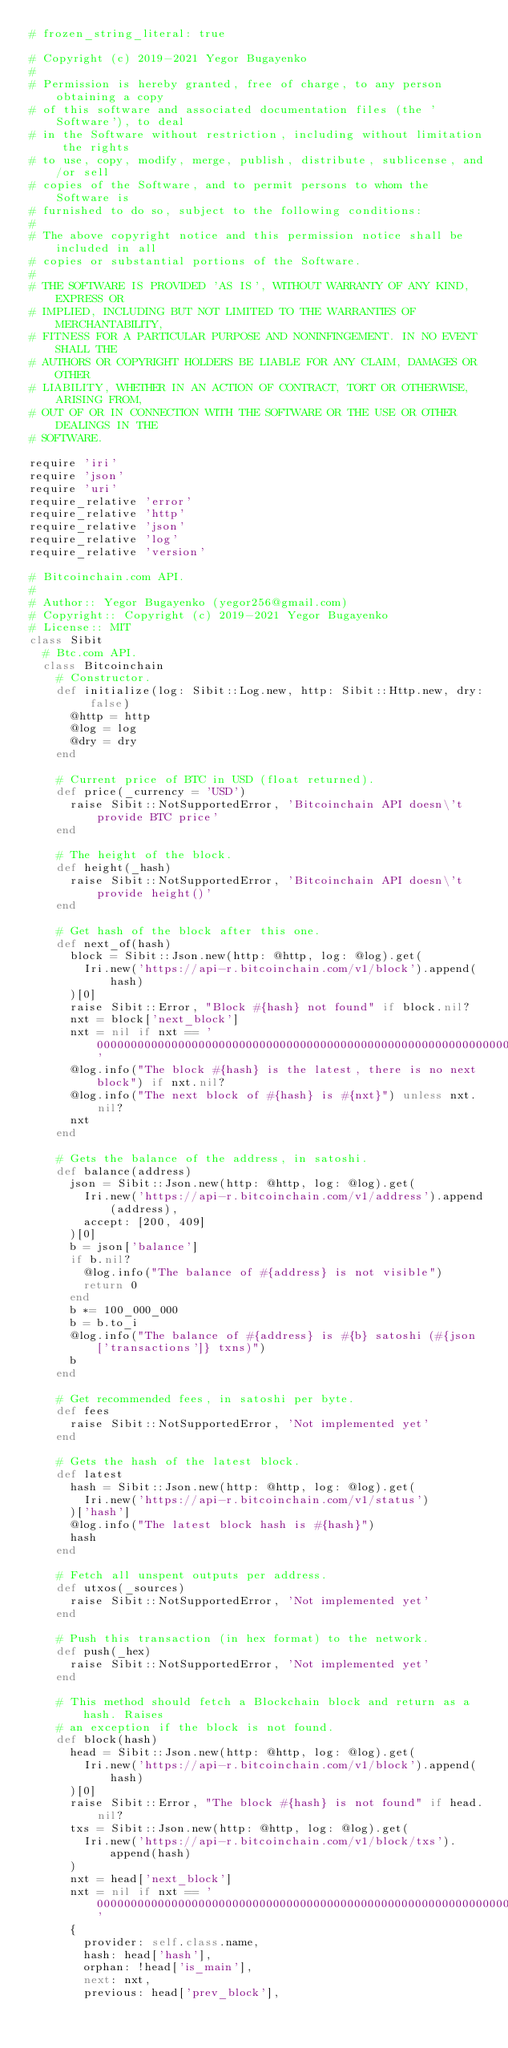<code> <loc_0><loc_0><loc_500><loc_500><_Ruby_># frozen_string_literal: true

# Copyright (c) 2019-2021 Yegor Bugayenko
#
# Permission is hereby granted, free of charge, to any person obtaining a copy
# of this software and associated documentation files (the 'Software'), to deal
# in the Software without restriction, including without limitation the rights
# to use, copy, modify, merge, publish, distribute, sublicense, and/or sell
# copies of the Software, and to permit persons to whom the Software is
# furnished to do so, subject to the following conditions:
#
# The above copyright notice and this permission notice shall be included in all
# copies or substantial portions of the Software.
#
# THE SOFTWARE IS PROVIDED 'AS IS', WITHOUT WARRANTY OF ANY KIND, EXPRESS OR
# IMPLIED, INCLUDING BUT NOT LIMITED TO THE WARRANTIES OF MERCHANTABILITY,
# FITNESS FOR A PARTICULAR PURPOSE AND NONINFINGEMENT. IN NO EVENT SHALL THE
# AUTHORS OR COPYRIGHT HOLDERS BE LIABLE FOR ANY CLAIM, DAMAGES OR OTHER
# LIABILITY, WHETHER IN AN ACTION OF CONTRACT, TORT OR OTHERWISE, ARISING FROM,
# OUT OF OR IN CONNECTION WITH THE SOFTWARE OR THE USE OR OTHER DEALINGS IN THE
# SOFTWARE.

require 'iri'
require 'json'
require 'uri'
require_relative 'error'
require_relative 'http'
require_relative 'json'
require_relative 'log'
require_relative 'version'

# Bitcoinchain.com API.
#
# Author:: Yegor Bugayenko (yegor256@gmail.com)
# Copyright:: Copyright (c) 2019-2021 Yegor Bugayenko
# License:: MIT
class Sibit
  # Btc.com API.
  class Bitcoinchain
    # Constructor.
    def initialize(log: Sibit::Log.new, http: Sibit::Http.new, dry: false)
      @http = http
      @log = log
      @dry = dry
    end

    # Current price of BTC in USD (float returned).
    def price(_currency = 'USD')
      raise Sibit::NotSupportedError, 'Bitcoinchain API doesn\'t provide BTC price'
    end

    # The height of the block.
    def height(_hash)
      raise Sibit::NotSupportedError, 'Bitcoinchain API doesn\'t provide height()'
    end

    # Get hash of the block after this one.
    def next_of(hash)
      block = Sibit::Json.new(http: @http, log: @log).get(
        Iri.new('https://api-r.bitcoinchain.com/v1/block').append(hash)
      )[0]
      raise Sibit::Error, "Block #{hash} not found" if block.nil?
      nxt = block['next_block']
      nxt = nil if nxt == '0000000000000000000000000000000000000000000000000000000000000000'
      @log.info("The block #{hash} is the latest, there is no next block") if nxt.nil?
      @log.info("The next block of #{hash} is #{nxt}") unless nxt.nil?
      nxt
    end

    # Gets the balance of the address, in satoshi.
    def balance(address)
      json = Sibit::Json.new(http: @http, log: @log).get(
        Iri.new('https://api-r.bitcoinchain.com/v1/address').append(address),
        accept: [200, 409]
      )[0]
      b = json['balance']
      if b.nil?
        @log.info("The balance of #{address} is not visible")
        return 0
      end
      b *= 100_000_000
      b = b.to_i
      @log.info("The balance of #{address} is #{b} satoshi (#{json['transactions']} txns)")
      b
    end

    # Get recommended fees, in satoshi per byte.
    def fees
      raise Sibit::NotSupportedError, 'Not implemented yet'
    end

    # Gets the hash of the latest block.
    def latest
      hash = Sibit::Json.new(http: @http, log: @log).get(
        Iri.new('https://api-r.bitcoinchain.com/v1/status')
      )['hash']
      @log.info("The latest block hash is #{hash}")
      hash
    end

    # Fetch all unspent outputs per address.
    def utxos(_sources)
      raise Sibit::NotSupportedError, 'Not implemented yet'
    end

    # Push this transaction (in hex format) to the network.
    def push(_hex)
      raise Sibit::NotSupportedError, 'Not implemented yet'
    end

    # This method should fetch a Blockchain block and return as a hash. Raises
    # an exception if the block is not found.
    def block(hash)
      head = Sibit::Json.new(http: @http, log: @log).get(
        Iri.new('https://api-r.bitcoinchain.com/v1/block').append(hash)
      )[0]
      raise Sibit::Error, "The block #{hash} is not found" if head.nil?
      txs = Sibit::Json.new(http: @http, log: @log).get(
        Iri.new('https://api-r.bitcoinchain.com/v1/block/txs').append(hash)
      )
      nxt = head['next_block']
      nxt = nil if nxt == '0000000000000000000000000000000000000000000000000000000000000000'
      {
        provider: self.class.name,
        hash: head['hash'],
        orphan: !head['is_main'],
        next: nxt,
        previous: head['prev_block'],</code> 